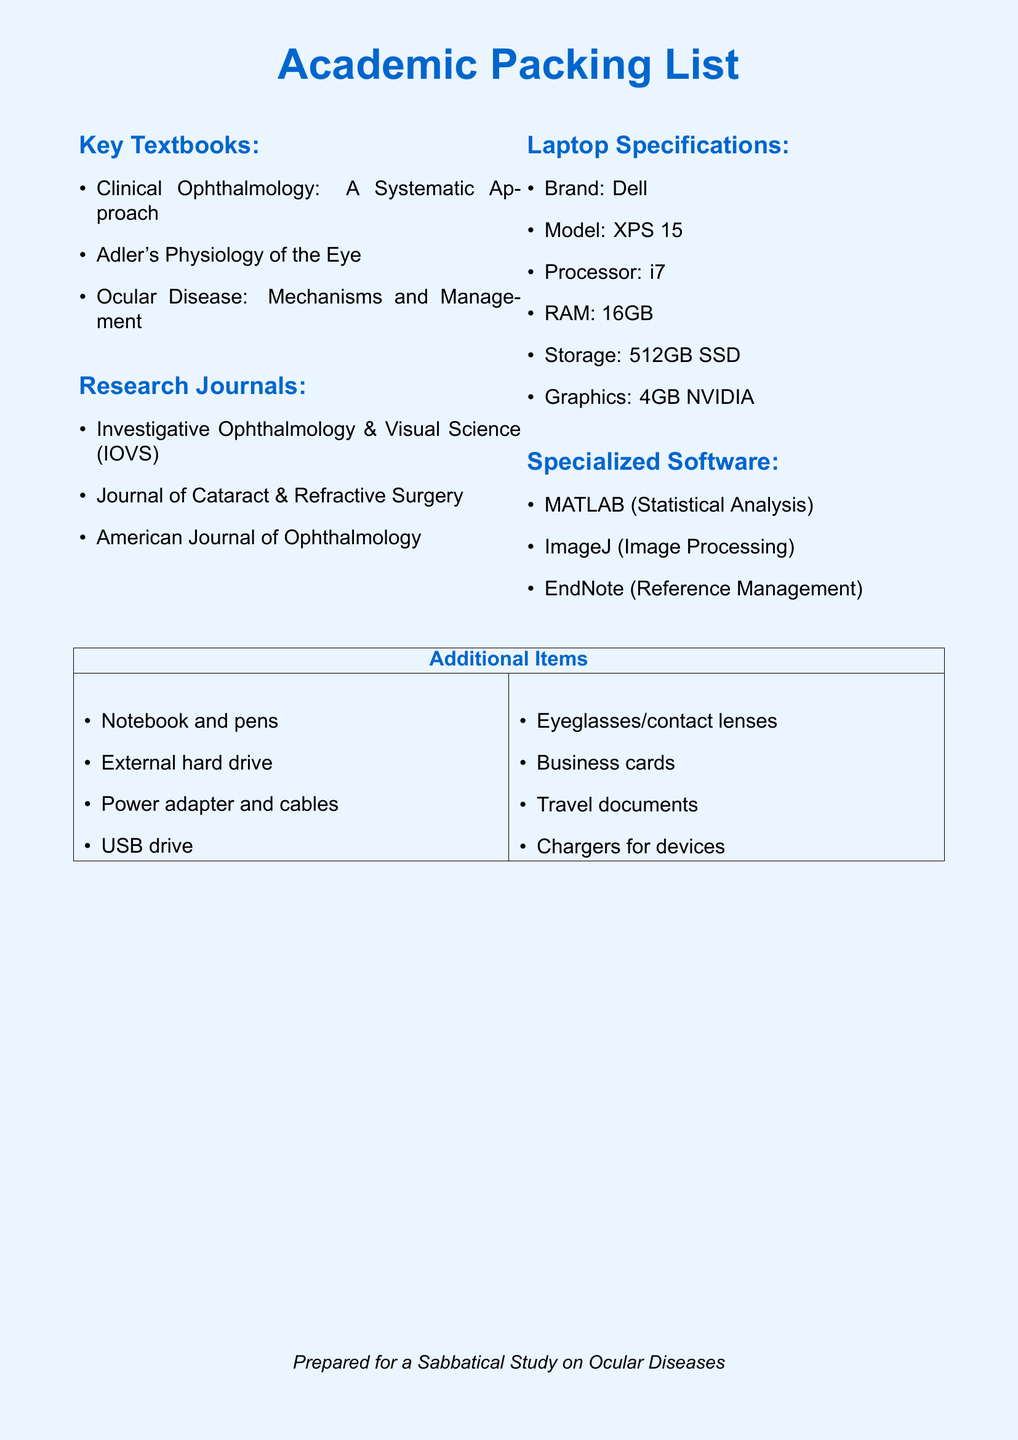What are the key textbooks listed? The document lists three key textbooks under the "Key Textbooks" section.
Answer: Clinical Ophthalmology: A Systematic Approach, Adler's Physiology of the Eye, Ocular Disease: Mechanisms and Management What is the model of the laptop specified? The document specifies the model of the laptop under "Laptop Specifications."
Answer: XPS 15 Which research journal focuses on cataract and refractive surgery? The document mentions a specific journal that addresses cataract and refractive surgery.
Answer: Journal of Cataract & Refractive Surgery What is the RAM size of the laptop? The document specifies the amount of RAM the laptop has.
Answer: 16GB Name one specialized software listed for reference management. The document lists specialized software for reference management in the "Specialized Software" section.
Answer: EndNote What type of drive is mentioned for storage in the laptop specifications? The document specifies the type of storage drive under "Laptop Specifications."
Answer: 512GB SSD How many additional items are listed in the table? The document contains a table with two columns of items, each listing four items, resulting in eight items total.
Answer: 8 Which color is used for the background of the document? The document specifies the background color used throughout the document.
Answer: lightblue 